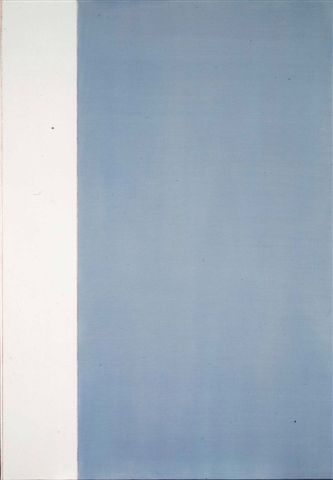What emotions or feelings does this artwork evoke? This artwork might evoke a range of emotions depending on the viewer. The stark contrast between the white and blue sections could elicit feelings of calmness, tranquility, and introspection. The gradient effect in the blue area might convey a sense of upward movement or enlightenment, suggesting progression or growth. The simplicity of the composition can also create a feeling of serenity and clarity, inviting viewers to find peace in minimalism. Alternatively, some viewers might feel a sense of emptiness or isolation due to the sparse design and lack of detailed elements. What might have inspired the artist to create this piece? The artist might have been inspired by a desire to explore the concepts of duality and balance, represented by the contrasting white and blue sections. The gradient in the blue section could reflect the artist's musings on transitions, changes, or the passage of time. Minimalism as a style often invites contemplation and introspection; thus, the artist may have aimed to prompt viewers to engage deeply with their own thoughts and emotions. Natural elements such as the sky or ocean, with their vast, uninterrupted expanses and changing shades, might also have influenced the artist's choice of color and composition. 